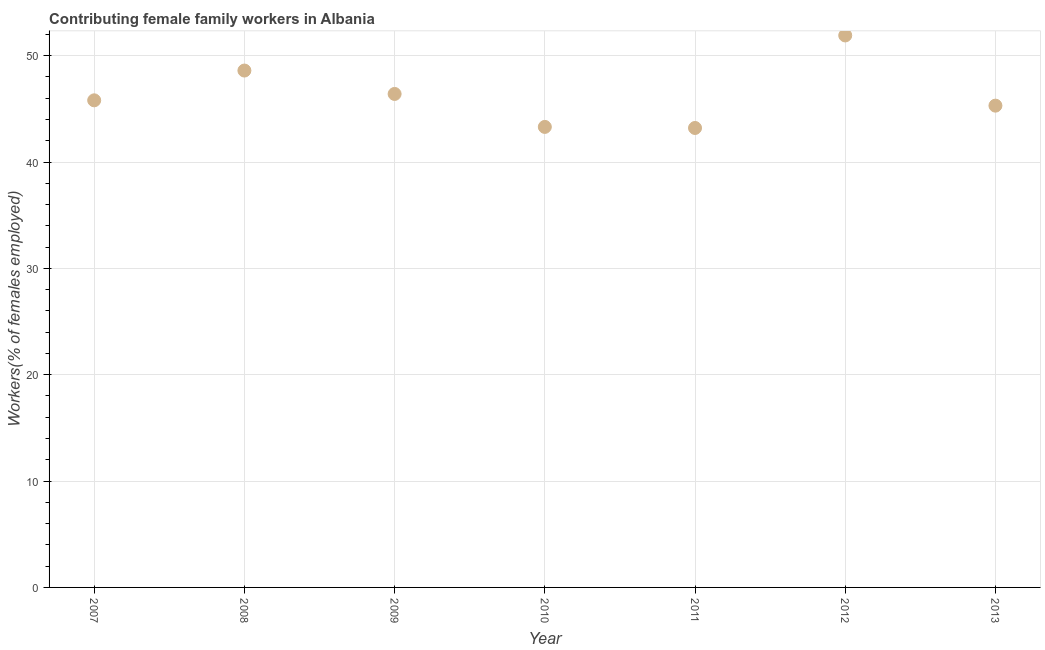What is the contributing female family workers in 2010?
Your response must be concise. 43.3. Across all years, what is the maximum contributing female family workers?
Provide a succinct answer. 51.9. Across all years, what is the minimum contributing female family workers?
Your response must be concise. 43.2. What is the sum of the contributing female family workers?
Ensure brevity in your answer.  324.5. What is the difference between the contributing female family workers in 2011 and 2013?
Provide a succinct answer. -2.1. What is the average contributing female family workers per year?
Your answer should be compact. 46.36. What is the median contributing female family workers?
Your answer should be compact. 45.8. Do a majority of the years between 2013 and 2008 (inclusive) have contributing female family workers greater than 36 %?
Give a very brief answer. Yes. What is the ratio of the contributing female family workers in 2007 to that in 2012?
Offer a very short reply. 0.88. Is the contributing female family workers in 2010 less than that in 2012?
Keep it short and to the point. Yes. Is the difference between the contributing female family workers in 2009 and 2011 greater than the difference between any two years?
Offer a terse response. No. What is the difference between the highest and the second highest contributing female family workers?
Offer a very short reply. 3.3. What is the difference between the highest and the lowest contributing female family workers?
Provide a short and direct response. 8.7. Does the contributing female family workers monotonically increase over the years?
Ensure brevity in your answer.  No. How many years are there in the graph?
Keep it short and to the point. 7. What is the difference between two consecutive major ticks on the Y-axis?
Your answer should be very brief. 10. Does the graph contain any zero values?
Your answer should be very brief. No. What is the title of the graph?
Offer a terse response. Contributing female family workers in Albania. What is the label or title of the X-axis?
Give a very brief answer. Year. What is the label or title of the Y-axis?
Provide a short and direct response. Workers(% of females employed). What is the Workers(% of females employed) in 2007?
Keep it short and to the point. 45.8. What is the Workers(% of females employed) in 2008?
Offer a very short reply. 48.6. What is the Workers(% of females employed) in 2009?
Your answer should be very brief. 46.4. What is the Workers(% of females employed) in 2010?
Your answer should be very brief. 43.3. What is the Workers(% of females employed) in 2011?
Give a very brief answer. 43.2. What is the Workers(% of females employed) in 2012?
Offer a terse response. 51.9. What is the Workers(% of females employed) in 2013?
Offer a very short reply. 45.3. What is the difference between the Workers(% of females employed) in 2007 and 2008?
Offer a very short reply. -2.8. What is the difference between the Workers(% of females employed) in 2007 and 2010?
Keep it short and to the point. 2.5. What is the difference between the Workers(% of females employed) in 2008 and 2010?
Keep it short and to the point. 5.3. What is the difference between the Workers(% of females employed) in 2008 and 2011?
Provide a succinct answer. 5.4. What is the difference between the Workers(% of females employed) in 2008 and 2012?
Make the answer very short. -3.3. What is the difference between the Workers(% of females employed) in 2008 and 2013?
Ensure brevity in your answer.  3.3. What is the difference between the Workers(% of females employed) in 2009 and 2011?
Provide a short and direct response. 3.2. What is the difference between the Workers(% of females employed) in 2012 and 2013?
Your response must be concise. 6.6. What is the ratio of the Workers(% of females employed) in 2007 to that in 2008?
Give a very brief answer. 0.94. What is the ratio of the Workers(% of females employed) in 2007 to that in 2010?
Your answer should be compact. 1.06. What is the ratio of the Workers(% of females employed) in 2007 to that in 2011?
Your answer should be compact. 1.06. What is the ratio of the Workers(% of females employed) in 2007 to that in 2012?
Your response must be concise. 0.88. What is the ratio of the Workers(% of females employed) in 2007 to that in 2013?
Make the answer very short. 1.01. What is the ratio of the Workers(% of females employed) in 2008 to that in 2009?
Ensure brevity in your answer.  1.05. What is the ratio of the Workers(% of females employed) in 2008 to that in 2010?
Ensure brevity in your answer.  1.12. What is the ratio of the Workers(% of females employed) in 2008 to that in 2011?
Your answer should be compact. 1.12. What is the ratio of the Workers(% of females employed) in 2008 to that in 2012?
Your answer should be compact. 0.94. What is the ratio of the Workers(% of females employed) in 2008 to that in 2013?
Provide a succinct answer. 1.07. What is the ratio of the Workers(% of females employed) in 2009 to that in 2010?
Provide a succinct answer. 1.07. What is the ratio of the Workers(% of females employed) in 2009 to that in 2011?
Keep it short and to the point. 1.07. What is the ratio of the Workers(% of females employed) in 2009 to that in 2012?
Keep it short and to the point. 0.89. What is the ratio of the Workers(% of females employed) in 2009 to that in 2013?
Make the answer very short. 1.02. What is the ratio of the Workers(% of females employed) in 2010 to that in 2012?
Your answer should be compact. 0.83. What is the ratio of the Workers(% of females employed) in 2010 to that in 2013?
Ensure brevity in your answer.  0.96. What is the ratio of the Workers(% of females employed) in 2011 to that in 2012?
Provide a succinct answer. 0.83. What is the ratio of the Workers(% of females employed) in 2011 to that in 2013?
Offer a terse response. 0.95. What is the ratio of the Workers(% of females employed) in 2012 to that in 2013?
Provide a short and direct response. 1.15. 